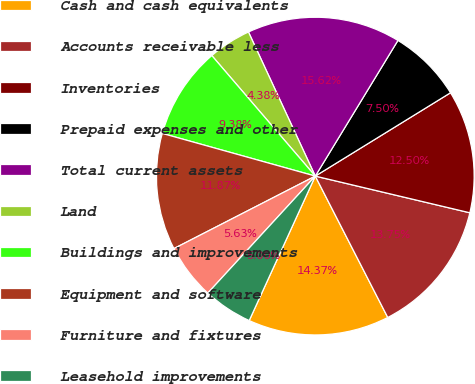Convert chart to OTSL. <chart><loc_0><loc_0><loc_500><loc_500><pie_chart><fcel>Cash and cash equivalents<fcel>Accounts receivable less<fcel>Inventories<fcel>Prepaid expenses and other<fcel>Total current assets<fcel>Land<fcel>Buildings and improvements<fcel>Equipment and software<fcel>Furniture and fixtures<fcel>Leasehold improvements<nl><fcel>14.37%<fcel>13.75%<fcel>12.5%<fcel>7.5%<fcel>15.62%<fcel>4.38%<fcel>9.38%<fcel>11.87%<fcel>5.63%<fcel>5.0%<nl></chart> 